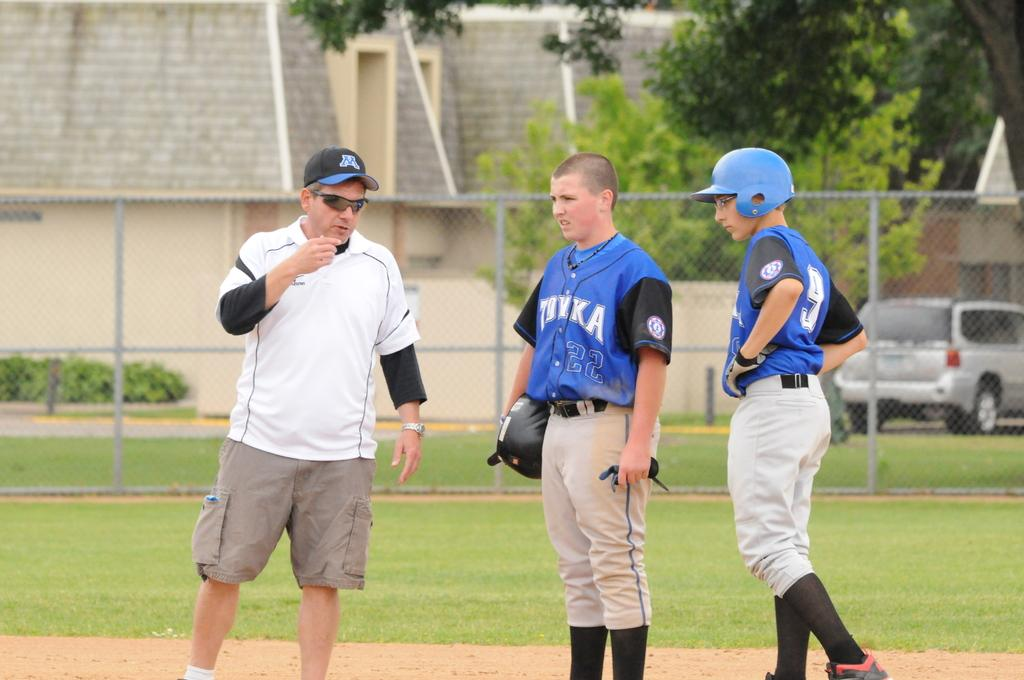Provide a one-sentence caption for the provided image. A young ball player in a number 9 shirt stands with his team mate and a man wearing a cap with an W on it. 